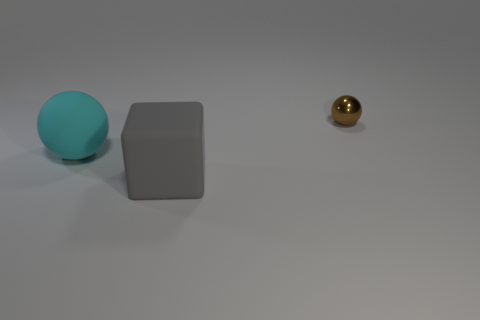There is a rubber object left of the big gray thing; what size is it?
Provide a succinct answer. Large. Are there any spheres of the same size as the gray rubber thing?
Keep it short and to the point. Yes. There is a ball that is left of the brown object; is its size the same as the small brown object?
Keep it short and to the point. No. What is the size of the cyan ball?
Your answer should be compact. Large. What color is the large matte thing that is behind the big gray rubber thing that is in front of the matte thing behind the large block?
Provide a short and direct response. Cyan. How many balls are both behind the big rubber sphere and to the left of the gray rubber block?
Provide a succinct answer. 0. What is the size of the cyan thing that is the same shape as the tiny brown object?
Your response must be concise. Large. There is a large matte thing in front of the sphere that is in front of the brown object; what number of cyan balls are left of it?
Your response must be concise. 1. What is the color of the thing in front of the matte object behind the cube?
Provide a succinct answer. Gray. How many other objects are the same material as the gray cube?
Your response must be concise. 1. 